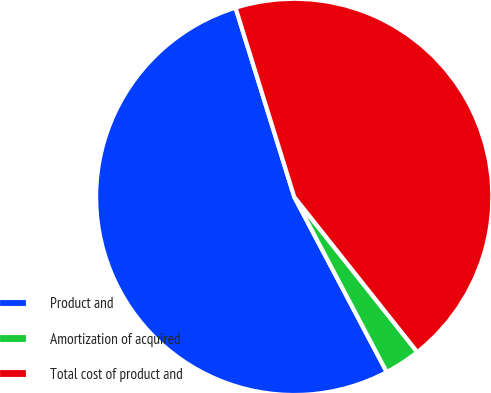<chart> <loc_0><loc_0><loc_500><loc_500><pie_chart><fcel>Product and<fcel>Amortization of acquired<fcel>Total cost of product and<nl><fcel>52.94%<fcel>2.94%<fcel>44.12%<nl></chart> 